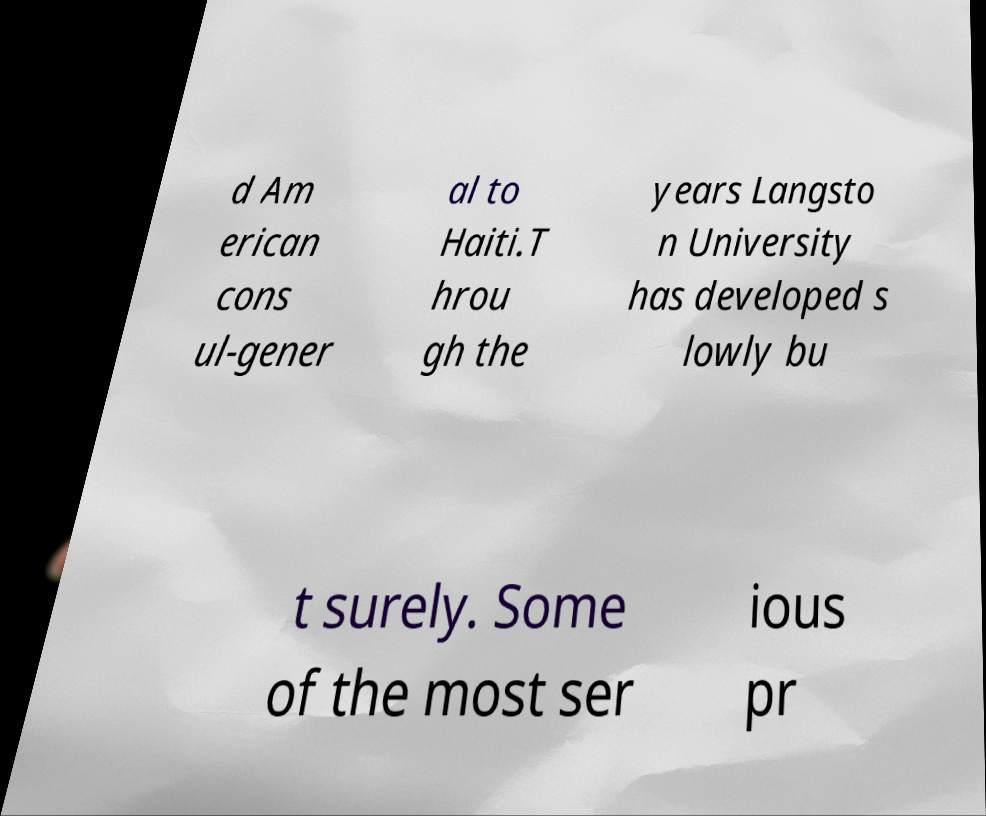Can you accurately transcribe the text from the provided image for me? d Am erican cons ul-gener al to Haiti.T hrou gh the years Langsto n University has developed s lowly bu t surely. Some of the most ser ious pr 